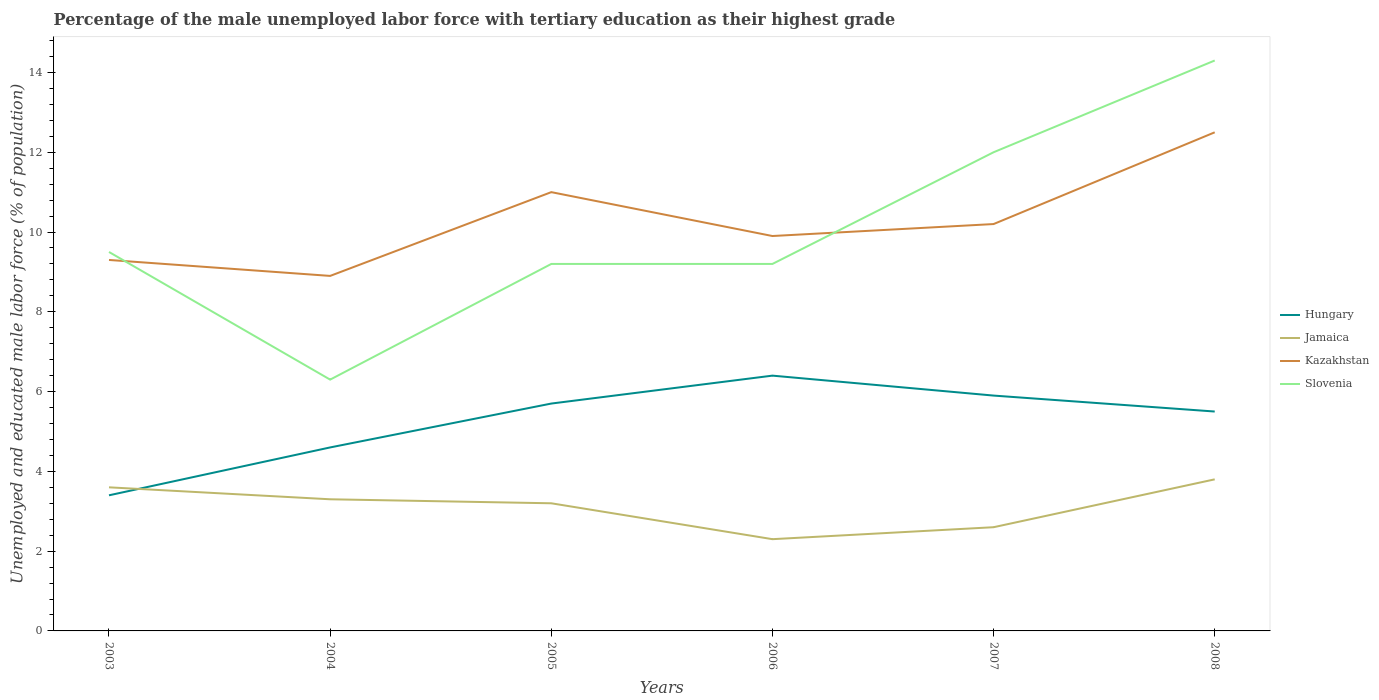How many different coloured lines are there?
Provide a succinct answer. 4. Does the line corresponding to Jamaica intersect with the line corresponding to Hungary?
Provide a succinct answer. Yes. Is the number of lines equal to the number of legend labels?
Keep it short and to the point. Yes. Across all years, what is the maximum percentage of the unemployed male labor force with tertiary education in Kazakhstan?
Offer a terse response. 8.9. In which year was the percentage of the unemployed male labor force with tertiary education in Jamaica maximum?
Your answer should be very brief. 2006. What is the difference between the highest and the second highest percentage of the unemployed male labor force with tertiary education in Jamaica?
Provide a short and direct response. 1.5. What is the difference between the highest and the lowest percentage of the unemployed male labor force with tertiary education in Jamaica?
Keep it short and to the point. 4. Is the percentage of the unemployed male labor force with tertiary education in Kazakhstan strictly greater than the percentage of the unemployed male labor force with tertiary education in Slovenia over the years?
Offer a terse response. No. How many lines are there?
Provide a short and direct response. 4. What is the difference between two consecutive major ticks on the Y-axis?
Offer a terse response. 2. Are the values on the major ticks of Y-axis written in scientific E-notation?
Offer a very short reply. No. Does the graph contain grids?
Keep it short and to the point. No. Where does the legend appear in the graph?
Offer a terse response. Center right. How many legend labels are there?
Offer a terse response. 4. How are the legend labels stacked?
Provide a succinct answer. Vertical. What is the title of the graph?
Your response must be concise. Percentage of the male unemployed labor force with tertiary education as their highest grade. What is the label or title of the X-axis?
Your response must be concise. Years. What is the label or title of the Y-axis?
Keep it short and to the point. Unemployed and educated male labor force (% of population). What is the Unemployed and educated male labor force (% of population) in Hungary in 2003?
Provide a succinct answer. 3.4. What is the Unemployed and educated male labor force (% of population) of Jamaica in 2003?
Your response must be concise. 3.6. What is the Unemployed and educated male labor force (% of population) in Kazakhstan in 2003?
Your answer should be compact. 9.3. What is the Unemployed and educated male labor force (% of population) of Slovenia in 2003?
Provide a short and direct response. 9.5. What is the Unemployed and educated male labor force (% of population) of Hungary in 2004?
Ensure brevity in your answer.  4.6. What is the Unemployed and educated male labor force (% of population) of Jamaica in 2004?
Ensure brevity in your answer.  3.3. What is the Unemployed and educated male labor force (% of population) in Kazakhstan in 2004?
Offer a very short reply. 8.9. What is the Unemployed and educated male labor force (% of population) in Slovenia in 2004?
Provide a short and direct response. 6.3. What is the Unemployed and educated male labor force (% of population) in Hungary in 2005?
Your answer should be very brief. 5.7. What is the Unemployed and educated male labor force (% of population) in Jamaica in 2005?
Give a very brief answer. 3.2. What is the Unemployed and educated male labor force (% of population) in Kazakhstan in 2005?
Provide a succinct answer. 11. What is the Unemployed and educated male labor force (% of population) of Slovenia in 2005?
Your answer should be compact. 9.2. What is the Unemployed and educated male labor force (% of population) in Hungary in 2006?
Your answer should be compact. 6.4. What is the Unemployed and educated male labor force (% of population) of Jamaica in 2006?
Give a very brief answer. 2.3. What is the Unemployed and educated male labor force (% of population) of Kazakhstan in 2006?
Offer a very short reply. 9.9. What is the Unemployed and educated male labor force (% of population) in Slovenia in 2006?
Give a very brief answer. 9.2. What is the Unemployed and educated male labor force (% of population) in Hungary in 2007?
Give a very brief answer. 5.9. What is the Unemployed and educated male labor force (% of population) of Jamaica in 2007?
Provide a short and direct response. 2.6. What is the Unemployed and educated male labor force (% of population) of Kazakhstan in 2007?
Offer a very short reply. 10.2. What is the Unemployed and educated male labor force (% of population) in Slovenia in 2007?
Offer a very short reply. 12. What is the Unemployed and educated male labor force (% of population) in Jamaica in 2008?
Offer a very short reply. 3.8. What is the Unemployed and educated male labor force (% of population) in Kazakhstan in 2008?
Offer a terse response. 12.5. What is the Unemployed and educated male labor force (% of population) of Slovenia in 2008?
Your answer should be compact. 14.3. Across all years, what is the maximum Unemployed and educated male labor force (% of population) of Hungary?
Provide a short and direct response. 6.4. Across all years, what is the maximum Unemployed and educated male labor force (% of population) of Jamaica?
Your answer should be very brief. 3.8. Across all years, what is the maximum Unemployed and educated male labor force (% of population) of Kazakhstan?
Offer a terse response. 12.5. Across all years, what is the maximum Unemployed and educated male labor force (% of population) of Slovenia?
Ensure brevity in your answer.  14.3. Across all years, what is the minimum Unemployed and educated male labor force (% of population) in Hungary?
Give a very brief answer. 3.4. Across all years, what is the minimum Unemployed and educated male labor force (% of population) in Jamaica?
Your response must be concise. 2.3. Across all years, what is the minimum Unemployed and educated male labor force (% of population) of Kazakhstan?
Your answer should be very brief. 8.9. Across all years, what is the minimum Unemployed and educated male labor force (% of population) in Slovenia?
Your answer should be very brief. 6.3. What is the total Unemployed and educated male labor force (% of population) in Hungary in the graph?
Your answer should be compact. 31.5. What is the total Unemployed and educated male labor force (% of population) in Kazakhstan in the graph?
Your answer should be very brief. 61.8. What is the total Unemployed and educated male labor force (% of population) in Slovenia in the graph?
Provide a short and direct response. 60.5. What is the difference between the Unemployed and educated male labor force (% of population) in Slovenia in 2003 and that in 2004?
Offer a very short reply. 3.2. What is the difference between the Unemployed and educated male labor force (% of population) in Hungary in 2003 and that in 2005?
Keep it short and to the point. -2.3. What is the difference between the Unemployed and educated male labor force (% of population) in Jamaica in 2003 and that in 2005?
Your answer should be compact. 0.4. What is the difference between the Unemployed and educated male labor force (% of population) of Kazakhstan in 2003 and that in 2005?
Ensure brevity in your answer.  -1.7. What is the difference between the Unemployed and educated male labor force (% of population) in Hungary in 2003 and that in 2006?
Your response must be concise. -3. What is the difference between the Unemployed and educated male labor force (% of population) of Jamaica in 2003 and that in 2006?
Ensure brevity in your answer.  1.3. What is the difference between the Unemployed and educated male labor force (% of population) in Kazakhstan in 2003 and that in 2006?
Give a very brief answer. -0.6. What is the difference between the Unemployed and educated male labor force (% of population) in Slovenia in 2003 and that in 2006?
Make the answer very short. 0.3. What is the difference between the Unemployed and educated male labor force (% of population) of Jamaica in 2003 and that in 2007?
Your response must be concise. 1. What is the difference between the Unemployed and educated male labor force (% of population) in Kazakhstan in 2003 and that in 2007?
Give a very brief answer. -0.9. What is the difference between the Unemployed and educated male labor force (% of population) in Slovenia in 2003 and that in 2007?
Keep it short and to the point. -2.5. What is the difference between the Unemployed and educated male labor force (% of population) in Jamaica in 2004 and that in 2005?
Offer a terse response. 0.1. What is the difference between the Unemployed and educated male labor force (% of population) in Jamaica in 2004 and that in 2006?
Offer a very short reply. 1. What is the difference between the Unemployed and educated male labor force (% of population) in Kazakhstan in 2004 and that in 2006?
Keep it short and to the point. -1. What is the difference between the Unemployed and educated male labor force (% of population) of Slovenia in 2004 and that in 2006?
Offer a very short reply. -2.9. What is the difference between the Unemployed and educated male labor force (% of population) of Hungary in 2004 and that in 2007?
Offer a terse response. -1.3. What is the difference between the Unemployed and educated male labor force (% of population) of Kazakhstan in 2004 and that in 2007?
Ensure brevity in your answer.  -1.3. What is the difference between the Unemployed and educated male labor force (% of population) of Slovenia in 2004 and that in 2007?
Offer a terse response. -5.7. What is the difference between the Unemployed and educated male labor force (% of population) of Hungary in 2004 and that in 2008?
Your response must be concise. -0.9. What is the difference between the Unemployed and educated male labor force (% of population) of Hungary in 2005 and that in 2006?
Give a very brief answer. -0.7. What is the difference between the Unemployed and educated male labor force (% of population) of Jamaica in 2005 and that in 2006?
Your response must be concise. 0.9. What is the difference between the Unemployed and educated male labor force (% of population) of Kazakhstan in 2005 and that in 2006?
Your answer should be very brief. 1.1. What is the difference between the Unemployed and educated male labor force (% of population) of Slovenia in 2005 and that in 2007?
Your answer should be compact. -2.8. What is the difference between the Unemployed and educated male labor force (% of population) in Kazakhstan in 2005 and that in 2008?
Offer a terse response. -1.5. What is the difference between the Unemployed and educated male labor force (% of population) in Hungary in 2006 and that in 2007?
Keep it short and to the point. 0.5. What is the difference between the Unemployed and educated male labor force (% of population) of Jamaica in 2006 and that in 2007?
Provide a short and direct response. -0.3. What is the difference between the Unemployed and educated male labor force (% of population) of Kazakhstan in 2006 and that in 2007?
Give a very brief answer. -0.3. What is the difference between the Unemployed and educated male labor force (% of population) of Slovenia in 2006 and that in 2007?
Provide a short and direct response. -2.8. What is the difference between the Unemployed and educated male labor force (% of population) of Kazakhstan in 2006 and that in 2008?
Offer a very short reply. -2.6. What is the difference between the Unemployed and educated male labor force (% of population) in Kazakhstan in 2007 and that in 2008?
Your response must be concise. -2.3. What is the difference between the Unemployed and educated male labor force (% of population) in Hungary in 2003 and the Unemployed and educated male labor force (% of population) in Slovenia in 2004?
Keep it short and to the point. -2.9. What is the difference between the Unemployed and educated male labor force (% of population) of Jamaica in 2003 and the Unemployed and educated male labor force (% of population) of Slovenia in 2004?
Your answer should be very brief. -2.7. What is the difference between the Unemployed and educated male labor force (% of population) in Hungary in 2003 and the Unemployed and educated male labor force (% of population) in Slovenia in 2005?
Offer a terse response. -5.8. What is the difference between the Unemployed and educated male labor force (% of population) in Jamaica in 2003 and the Unemployed and educated male labor force (% of population) in Kazakhstan in 2005?
Offer a very short reply. -7.4. What is the difference between the Unemployed and educated male labor force (% of population) of Kazakhstan in 2003 and the Unemployed and educated male labor force (% of population) of Slovenia in 2005?
Make the answer very short. 0.1. What is the difference between the Unemployed and educated male labor force (% of population) in Hungary in 2003 and the Unemployed and educated male labor force (% of population) in Jamaica in 2006?
Your answer should be very brief. 1.1. What is the difference between the Unemployed and educated male labor force (% of population) in Hungary in 2003 and the Unemployed and educated male labor force (% of population) in Kazakhstan in 2006?
Give a very brief answer. -6.5. What is the difference between the Unemployed and educated male labor force (% of population) of Hungary in 2003 and the Unemployed and educated male labor force (% of population) of Slovenia in 2006?
Provide a succinct answer. -5.8. What is the difference between the Unemployed and educated male labor force (% of population) in Jamaica in 2003 and the Unemployed and educated male labor force (% of population) in Kazakhstan in 2006?
Make the answer very short. -6.3. What is the difference between the Unemployed and educated male labor force (% of population) in Hungary in 2003 and the Unemployed and educated male labor force (% of population) in Kazakhstan in 2007?
Ensure brevity in your answer.  -6.8. What is the difference between the Unemployed and educated male labor force (% of population) in Hungary in 2003 and the Unemployed and educated male labor force (% of population) in Kazakhstan in 2008?
Provide a succinct answer. -9.1. What is the difference between the Unemployed and educated male labor force (% of population) in Jamaica in 2003 and the Unemployed and educated male labor force (% of population) in Slovenia in 2008?
Ensure brevity in your answer.  -10.7. What is the difference between the Unemployed and educated male labor force (% of population) in Hungary in 2004 and the Unemployed and educated male labor force (% of population) in Jamaica in 2005?
Provide a short and direct response. 1.4. What is the difference between the Unemployed and educated male labor force (% of population) in Jamaica in 2004 and the Unemployed and educated male labor force (% of population) in Slovenia in 2005?
Keep it short and to the point. -5.9. What is the difference between the Unemployed and educated male labor force (% of population) in Kazakhstan in 2004 and the Unemployed and educated male labor force (% of population) in Slovenia in 2005?
Your answer should be compact. -0.3. What is the difference between the Unemployed and educated male labor force (% of population) of Hungary in 2004 and the Unemployed and educated male labor force (% of population) of Jamaica in 2006?
Offer a very short reply. 2.3. What is the difference between the Unemployed and educated male labor force (% of population) of Hungary in 2004 and the Unemployed and educated male labor force (% of population) of Kazakhstan in 2006?
Ensure brevity in your answer.  -5.3. What is the difference between the Unemployed and educated male labor force (% of population) in Hungary in 2004 and the Unemployed and educated male labor force (% of population) in Slovenia in 2006?
Provide a short and direct response. -4.6. What is the difference between the Unemployed and educated male labor force (% of population) of Jamaica in 2004 and the Unemployed and educated male labor force (% of population) of Kazakhstan in 2006?
Give a very brief answer. -6.6. What is the difference between the Unemployed and educated male labor force (% of population) in Kazakhstan in 2004 and the Unemployed and educated male labor force (% of population) in Slovenia in 2006?
Ensure brevity in your answer.  -0.3. What is the difference between the Unemployed and educated male labor force (% of population) of Hungary in 2004 and the Unemployed and educated male labor force (% of population) of Jamaica in 2007?
Ensure brevity in your answer.  2. What is the difference between the Unemployed and educated male labor force (% of population) in Hungary in 2004 and the Unemployed and educated male labor force (% of population) in Slovenia in 2007?
Offer a very short reply. -7.4. What is the difference between the Unemployed and educated male labor force (% of population) in Jamaica in 2004 and the Unemployed and educated male labor force (% of population) in Kazakhstan in 2007?
Make the answer very short. -6.9. What is the difference between the Unemployed and educated male labor force (% of population) of Hungary in 2004 and the Unemployed and educated male labor force (% of population) of Kazakhstan in 2008?
Your answer should be very brief. -7.9. What is the difference between the Unemployed and educated male labor force (% of population) of Hungary in 2004 and the Unemployed and educated male labor force (% of population) of Slovenia in 2008?
Your answer should be compact. -9.7. What is the difference between the Unemployed and educated male labor force (% of population) of Jamaica in 2004 and the Unemployed and educated male labor force (% of population) of Kazakhstan in 2008?
Make the answer very short. -9.2. What is the difference between the Unemployed and educated male labor force (% of population) of Hungary in 2005 and the Unemployed and educated male labor force (% of population) of Jamaica in 2006?
Keep it short and to the point. 3.4. What is the difference between the Unemployed and educated male labor force (% of population) in Hungary in 2005 and the Unemployed and educated male labor force (% of population) in Slovenia in 2006?
Your answer should be compact. -3.5. What is the difference between the Unemployed and educated male labor force (% of population) in Jamaica in 2005 and the Unemployed and educated male labor force (% of population) in Kazakhstan in 2006?
Provide a short and direct response. -6.7. What is the difference between the Unemployed and educated male labor force (% of population) of Jamaica in 2005 and the Unemployed and educated male labor force (% of population) of Slovenia in 2006?
Give a very brief answer. -6. What is the difference between the Unemployed and educated male labor force (% of population) in Hungary in 2005 and the Unemployed and educated male labor force (% of population) in Jamaica in 2007?
Your answer should be very brief. 3.1. What is the difference between the Unemployed and educated male labor force (% of population) in Hungary in 2005 and the Unemployed and educated male labor force (% of population) in Jamaica in 2008?
Your answer should be compact. 1.9. What is the difference between the Unemployed and educated male labor force (% of population) of Jamaica in 2005 and the Unemployed and educated male labor force (% of population) of Kazakhstan in 2008?
Your answer should be very brief. -9.3. What is the difference between the Unemployed and educated male labor force (% of population) in Jamaica in 2005 and the Unemployed and educated male labor force (% of population) in Slovenia in 2008?
Offer a very short reply. -11.1. What is the difference between the Unemployed and educated male labor force (% of population) of Hungary in 2006 and the Unemployed and educated male labor force (% of population) of Jamaica in 2007?
Keep it short and to the point. 3.8. What is the difference between the Unemployed and educated male labor force (% of population) in Hungary in 2006 and the Unemployed and educated male labor force (% of population) in Slovenia in 2007?
Your response must be concise. -5.6. What is the difference between the Unemployed and educated male labor force (% of population) in Jamaica in 2006 and the Unemployed and educated male labor force (% of population) in Kazakhstan in 2007?
Provide a short and direct response. -7.9. What is the difference between the Unemployed and educated male labor force (% of population) in Hungary in 2006 and the Unemployed and educated male labor force (% of population) in Jamaica in 2008?
Offer a very short reply. 2.6. What is the difference between the Unemployed and educated male labor force (% of population) in Hungary in 2006 and the Unemployed and educated male labor force (% of population) in Kazakhstan in 2008?
Your answer should be very brief. -6.1. What is the difference between the Unemployed and educated male labor force (% of population) of Kazakhstan in 2006 and the Unemployed and educated male labor force (% of population) of Slovenia in 2008?
Ensure brevity in your answer.  -4.4. What is the difference between the Unemployed and educated male labor force (% of population) of Hungary in 2007 and the Unemployed and educated male labor force (% of population) of Jamaica in 2008?
Give a very brief answer. 2.1. What is the difference between the Unemployed and educated male labor force (% of population) in Jamaica in 2007 and the Unemployed and educated male labor force (% of population) in Kazakhstan in 2008?
Offer a very short reply. -9.9. What is the difference between the Unemployed and educated male labor force (% of population) of Jamaica in 2007 and the Unemployed and educated male labor force (% of population) of Slovenia in 2008?
Keep it short and to the point. -11.7. What is the difference between the Unemployed and educated male labor force (% of population) of Kazakhstan in 2007 and the Unemployed and educated male labor force (% of population) of Slovenia in 2008?
Provide a short and direct response. -4.1. What is the average Unemployed and educated male labor force (% of population) of Hungary per year?
Your answer should be compact. 5.25. What is the average Unemployed and educated male labor force (% of population) of Jamaica per year?
Ensure brevity in your answer.  3.13. What is the average Unemployed and educated male labor force (% of population) in Slovenia per year?
Keep it short and to the point. 10.08. In the year 2003, what is the difference between the Unemployed and educated male labor force (% of population) in Hungary and Unemployed and educated male labor force (% of population) in Jamaica?
Provide a succinct answer. -0.2. In the year 2003, what is the difference between the Unemployed and educated male labor force (% of population) in Hungary and Unemployed and educated male labor force (% of population) in Kazakhstan?
Your answer should be very brief. -5.9. In the year 2003, what is the difference between the Unemployed and educated male labor force (% of population) in Jamaica and Unemployed and educated male labor force (% of population) in Kazakhstan?
Ensure brevity in your answer.  -5.7. In the year 2003, what is the difference between the Unemployed and educated male labor force (% of population) in Jamaica and Unemployed and educated male labor force (% of population) in Slovenia?
Give a very brief answer. -5.9. In the year 2004, what is the difference between the Unemployed and educated male labor force (% of population) in Hungary and Unemployed and educated male labor force (% of population) in Jamaica?
Give a very brief answer. 1.3. In the year 2004, what is the difference between the Unemployed and educated male labor force (% of population) of Hungary and Unemployed and educated male labor force (% of population) of Kazakhstan?
Your answer should be compact. -4.3. In the year 2004, what is the difference between the Unemployed and educated male labor force (% of population) in Jamaica and Unemployed and educated male labor force (% of population) in Kazakhstan?
Your answer should be compact. -5.6. In the year 2004, what is the difference between the Unemployed and educated male labor force (% of population) in Jamaica and Unemployed and educated male labor force (% of population) in Slovenia?
Make the answer very short. -3. In the year 2005, what is the difference between the Unemployed and educated male labor force (% of population) of Kazakhstan and Unemployed and educated male labor force (% of population) of Slovenia?
Make the answer very short. 1.8. In the year 2006, what is the difference between the Unemployed and educated male labor force (% of population) of Hungary and Unemployed and educated male labor force (% of population) of Jamaica?
Give a very brief answer. 4.1. In the year 2006, what is the difference between the Unemployed and educated male labor force (% of population) of Hungary and Unemployed and educated male labor force (% of population) of Slovenia?
Provide a short and direct response. -2.8. In the year 2006, what is the difference between the Unemployed and educated male labor force (% of population) in Jamaica and Unemployed and educated male labor force (% of population) in Kazakhstan?
Keep it short and to the point. -7.6. In the year 2006, what is the difference between the Unemployed and educated male labor force (% of population) in Jamaica and Unemployed and educated male labor force (% of population) in Slovenia?
Your answer should be compact. -6.9. In the year 2007, what is the difference between the Unemployed and educated male labor force (% of population) of Hungary and Unemployed and educated male labor force (% of population) of Kazakhstan?
Provide a short and direct response. -4.3. In the year 2007, what is the difference between the Unemployed and educated male labor force (% of population) of Jamaica and Unemployed and educated male labor force (% of population) of Kazakhstan?
Provide a succinct answer. -7.6. In the year 2007, what is the difference between the Unemployed and educated male labor force (% of population) in Jamaica and Unemployed and educated male labor force (% of population) in Slovenia?
Offer a very short reply. -9.4. In the year 2007, what is the difference between the Unemployed and educated male labor force (% of population) in Kazakhstan and Unemployed and educated male labor force (% of population) in Slovenia?
Ensure brevity in your answer.  -1.8. In the year 2008, what is the difference between the Unemployed and educated male labor force (% of population) in Hungary and Unemployed and educated male labor force (% of population) in Jamaica?
Offer a terse response. 1.7. In the year 2008, what is the difference between the Unemployed and educated male labor force (% of population) in Hungary and Unemployed and educated male labor force (% of population) in Slovenia?
Provide a short and direct response. -8.8. In the year 2008, what is the difference between the Unemployed and educated male labor force (% of population) in Jamaica and Unemployed and educated male labor force (% of population) in Kazakhstan?
Provide a short and direct response. -8.7. In the year 2008, what is the difference between the Unemployed and educated male labor force (% of population) of Jamaica and Unemployed and educated male labor force (% of population) of Slovenia?
Offer a terse response. -10.5. In the year 2008, what is the difference between the Unemployed and educated male labor force (% of population) in Kazakhstan and Unemployed and educated male labor force (% of population) in Slovenia?
Your answer should be very brief. -1.8. What is the ratio of the Unemployed and educated male labor force (% of population) in Hungary in 2003 to that in 2004?
Give a very brief answer. 0.74. What is the ratio of the Unemployed and educated male labor force (% of population) in Jamaica in 2003 to that in 2004?
Your response must be concise. 1.09. What is the ratio of the Unemployed and educated male labor force (% of population) in Kazakhstan in 2003 to that in 2004?
Your answer should be compact. 1.04. What is the ratio of the Unemployed and educated male labor force (% of population) of Slovenia in 2003 to that in 2004?
Your answer should be compact. 1.51. What is the ratio of the Unemployed and educated male labor force (% of population) of Hungary in 2003 to that in 2005?
Ensure brevity in your answer.  0.6. What is the ratio of the Unemployed and educated male labor force (% of population) in Jamaica in 2003 to that in 2005?
Offer a very short reply. 1.12. What is the ratio of the Unemployed and educated male labor force (% of population) in Kazakhstan in 2003 to that in 2005?
Provide a short and direct response. 0.85. What is the ratio of the Unemployed and educated male labor force (% of population) of Slovenia in 2003 to that in 2005?
Provide a short and direct response. 1.03. What is the ratio of the Unemployed and educated male labor force (% of population) of Hungary in 2003 to that in 2006?
Provide a succinct answer. 0.53. What is the ratio of the Unemployed and educated male labor force (% of population) in Jamaica in 2003 to that in 2006?
Give a very brief answer. 1.57. What is the ratio of the Unemployed and educated male labor force (% of population) in Kazakhstan in 2003 to that in 2006?
Offer a very short reply. 0.94. What is the ratio of the Unemployed and educated male labor force (% of population) of Slovenia in 2003 to that in 2006?
Your answer should be compact. 1.03. What is the ratio of the Unemployed and educated male labor force (% of population) in Hungary in 2003 to that in 2007?
Your answer should be compact. 0.58. What is the ratio of the Unemployed and educated male labor force (% of population) of Jamaica in 2003 to that in 2007?
Ensure brevity in your answer.  1.38. What is the ratio of the Unemployed and educated male labor force (% of population) of Kazakhstan in 2003 to that in 2007?
Give a very brief answer. 0.91. What is the ratio of the Unemployed and educated male labor force (% of population) in Slovenia in 2003 to that in 2007?
Make the answer very short. 0.79. What is the ratio of the Unemployed and educated male labor force (% of population) in Hungary in 2003 to that in 2008?
Your response must be concise. 0.62. What is the ratio of the Unemployed and educated male labor force (% of population) in Kazakhstan in 2003 to that in 2008?
Make the answer very short. 0.74. What is the ratio of the Unemployed and educated male labor force (% of population) of Slovenia in 2003 to that in 2008?
Keep it short and to the point. 0.66. What is the ratio of the Unemployed and educated male labor force (% of population) in Hungary in 2004 to that in 2005?
Give a very brief answer. 0.81. What is the ratio of the Unemployed and educated male labor force (% of population) of Jamaica in 2004 to that in 2005?
Your response must be concise. 1.03. What is the ratio of the Unemployed and educated male labor force (% of population) in Kazakhstan in 2004 to that in 2005?
Give a very brief answer. 0.81. What is the ratio of the Unemployed and educated male labor force (% of population) in Slovenia in 2004 to that in 2005?
Provide a succinct answer. 0.68. What is the ratio of the Unemployed and educated male labor force (% of population) of Hungary in 2004 to that in 2006?
Make the answer very short. 0.72. What is the ratio of the Unemployed and educated male labor force (% of population) of Jamaica in 2004 to that in 2006?
Your answer should be very brief. 1.43. What is the ratio of the Unemployed and educated male labor force (% of population) in Kazakhstan in 2004 to that in 2006?
Keep it short and to the point. 0.9. What is the ratio of the Unemployed and educated male labor force (% of population) in Slovenia in 2004 to that in 2006?
Keep it short and to the point. 0.68. What is the ratio of the Unemployed and educated male labor force (% of population) in Hungary in 2004 to that in 2007?
Make the answer very short. 0.78. What is the ratio of the Unemployed and educated male labor force (% of population) in Jamaica in 2004 to that in 2007?
Your answer should be compact. 1.27. What is the ratio of the Unemployed and educated male labor force (% of population) in Kazakhstan in 2004 to that in 2007?
Offer a terse response. 0.87. What is the ratio of the Unemployed and educated male labor force (% of population) of Slovenia in 2004 to that in 2007?
Keep it short and to the point. 0.53. What is the ratio of the Unemployed and educated male labor force (% of population) in Hungary in 2004 to that in 2008?
Your response must be concise. 0.84. What is the ratio of the Unemployed and educated male labor force (% of population) in Jamaica in 2004 to that in 2008?
Offer a very short reply. 0.87. What is the ratio of the Unemployed and educated male labor force (% of population) of Kazakhstan in 2004 to that in 2008?
Your answer should be compact. 0.71. What is the ratio of the Unemployed and educated male labor force (% of population) of Slovenia in 2004 to that in 2008?
Provide a short and direct response. 0.44. What is the ratio of the Unemployed and educated male labor force (% of population) of Hungary in 2005 to that in 2006?
Your answer should be compact. 0.89. What is the ratio of the Unemployed and educated male labor force (% of population) in Jamaica in 2005 to that in 2006?
Your answer should be compact. 1.39. What is the ratio of the Unemployed and educated male labor force (% of population) of Kazakhstan in 2005 to that in 2006?
Provide a succinct answer. 1.11. What is the ratio of the Unemployed and educated male labor force (% of population) in Slovenia in 2005 to that in 2006?
Offer a terse response. 1. What is the ratio of the Unemployed and educated male labor force (% of population) of Hungary in 2005 to that in 2007?
Provide a succinct answer. 0.97. What is the ratio of the Unemployed and educated male labor force (% of population) in Jamaica in 2005 to that in 2007?
Provide a short and direct response. 1.23. What is the ratio of the Unemployed and educated male labor force (% of population) in Kazakhstan in 2005 to that in 2007?
Ensure brevity in your answer.  1.08. What is the ratio of the Unemployed and educated male labor force (% of population) of Slovenia in 2005 to that in 2007?
Offer a terse response. 0.77. What is the ratio of the Unemployed and educated male labor force (% of population) in Hungary in 2005 to that in 2008?
Give a very brief answer. 1.04. What is the ratio of the Unemployed and educated male labor force (% of population) of Jamaica in 2005 to that in 2008?
Give a very brief answer. 0.84. What is the ratio of the Unemployed and educated male labor force (% of population) of Slovenia in 2005 to that in 2008?
Offer a terse response. 0.64. What is the ratio of the Unemployed and educated male labor force (% of population) of Hungary in 2006 to that in 2007?
Make the answer very short. 1.08. What is the ratio of the Unemployed and educated male labor force (% of population) of Jamaica in 2006 to that in 2007?
Your response must be concise. 0.88. What is the ratio of the Unemployed and educated male labor force (% of population) in Kazakhstan in 2006 to that in 2007?
Offer a terse response. 0.97. What is the ratio of the Unemployed and educated male labor force (% of population) in Slovenia in 2006 to that in 2007?
Offer a terse response. 0.77. What is the ratio of the Unemployed and educated male labor force (% of population) in Hungary in 2006 to that in 2008?
Offer a terse response. 1.16. What is the ratio of the Unemployed and educated male labor force (% of population) of Jamaica in 2006 to that in 2008?
Offer a very short reply. 0.61. What is the ratio of the Unemployed and educated male labor force (% of population) of Kazakhstan in 2006 to that in 2008?
Provide a succinct answer. 0.79. What is the ratio of the Unemployed and educated male labor force (% of population) in Slovenia in 2006 to that in 2008?
Give a very brief answer. 0.64. What is the ratio of the Unemployed and educated male labor force (% of population) in Hungary in 2007 to that in 2008?
Provide a short and direct response. 1.07. What is the ratio of the Unemployed and educated male labor force (% of population) of Jamaica in 2007 to that in 2008?
Provide a succinct answer. 0.68. What is the ratio of the Unemployed and educated male labor force (% of population) of Kazakhstan in 2007 to that in 2008?
Your answer should be compact. 0.82. What is the ratio of the Unemployed and educated male labor force (% of population) of Slovenia in 2007 to that in 2008?
Make the answer very short. 0.84. What is the difference between the highest and the second highest Unemployed and educated male labor force (% of population) of Hungary?
Provide a succinct answer. 0.5. What is the difference between the highest and the second highest Unemployed and educated male labor force (% of population) in Jamaica?
Ensure brevity in your answer.  0.2. What is the difference between the highest and the second highest Unemployed and educated male labor force (% of population) of Kazakhstan?
Ensure brevity in your answer.  1.5. What is the difference between the highest and the lowest Unemployed and educated male labor force (% of population) of Jamaica?
Make the answer very short. 1.5. What is the difference between the highest and the lowest Unemployed and educated male labor force (% of population) in Slovenia?
Offer a very short reply. 8. 